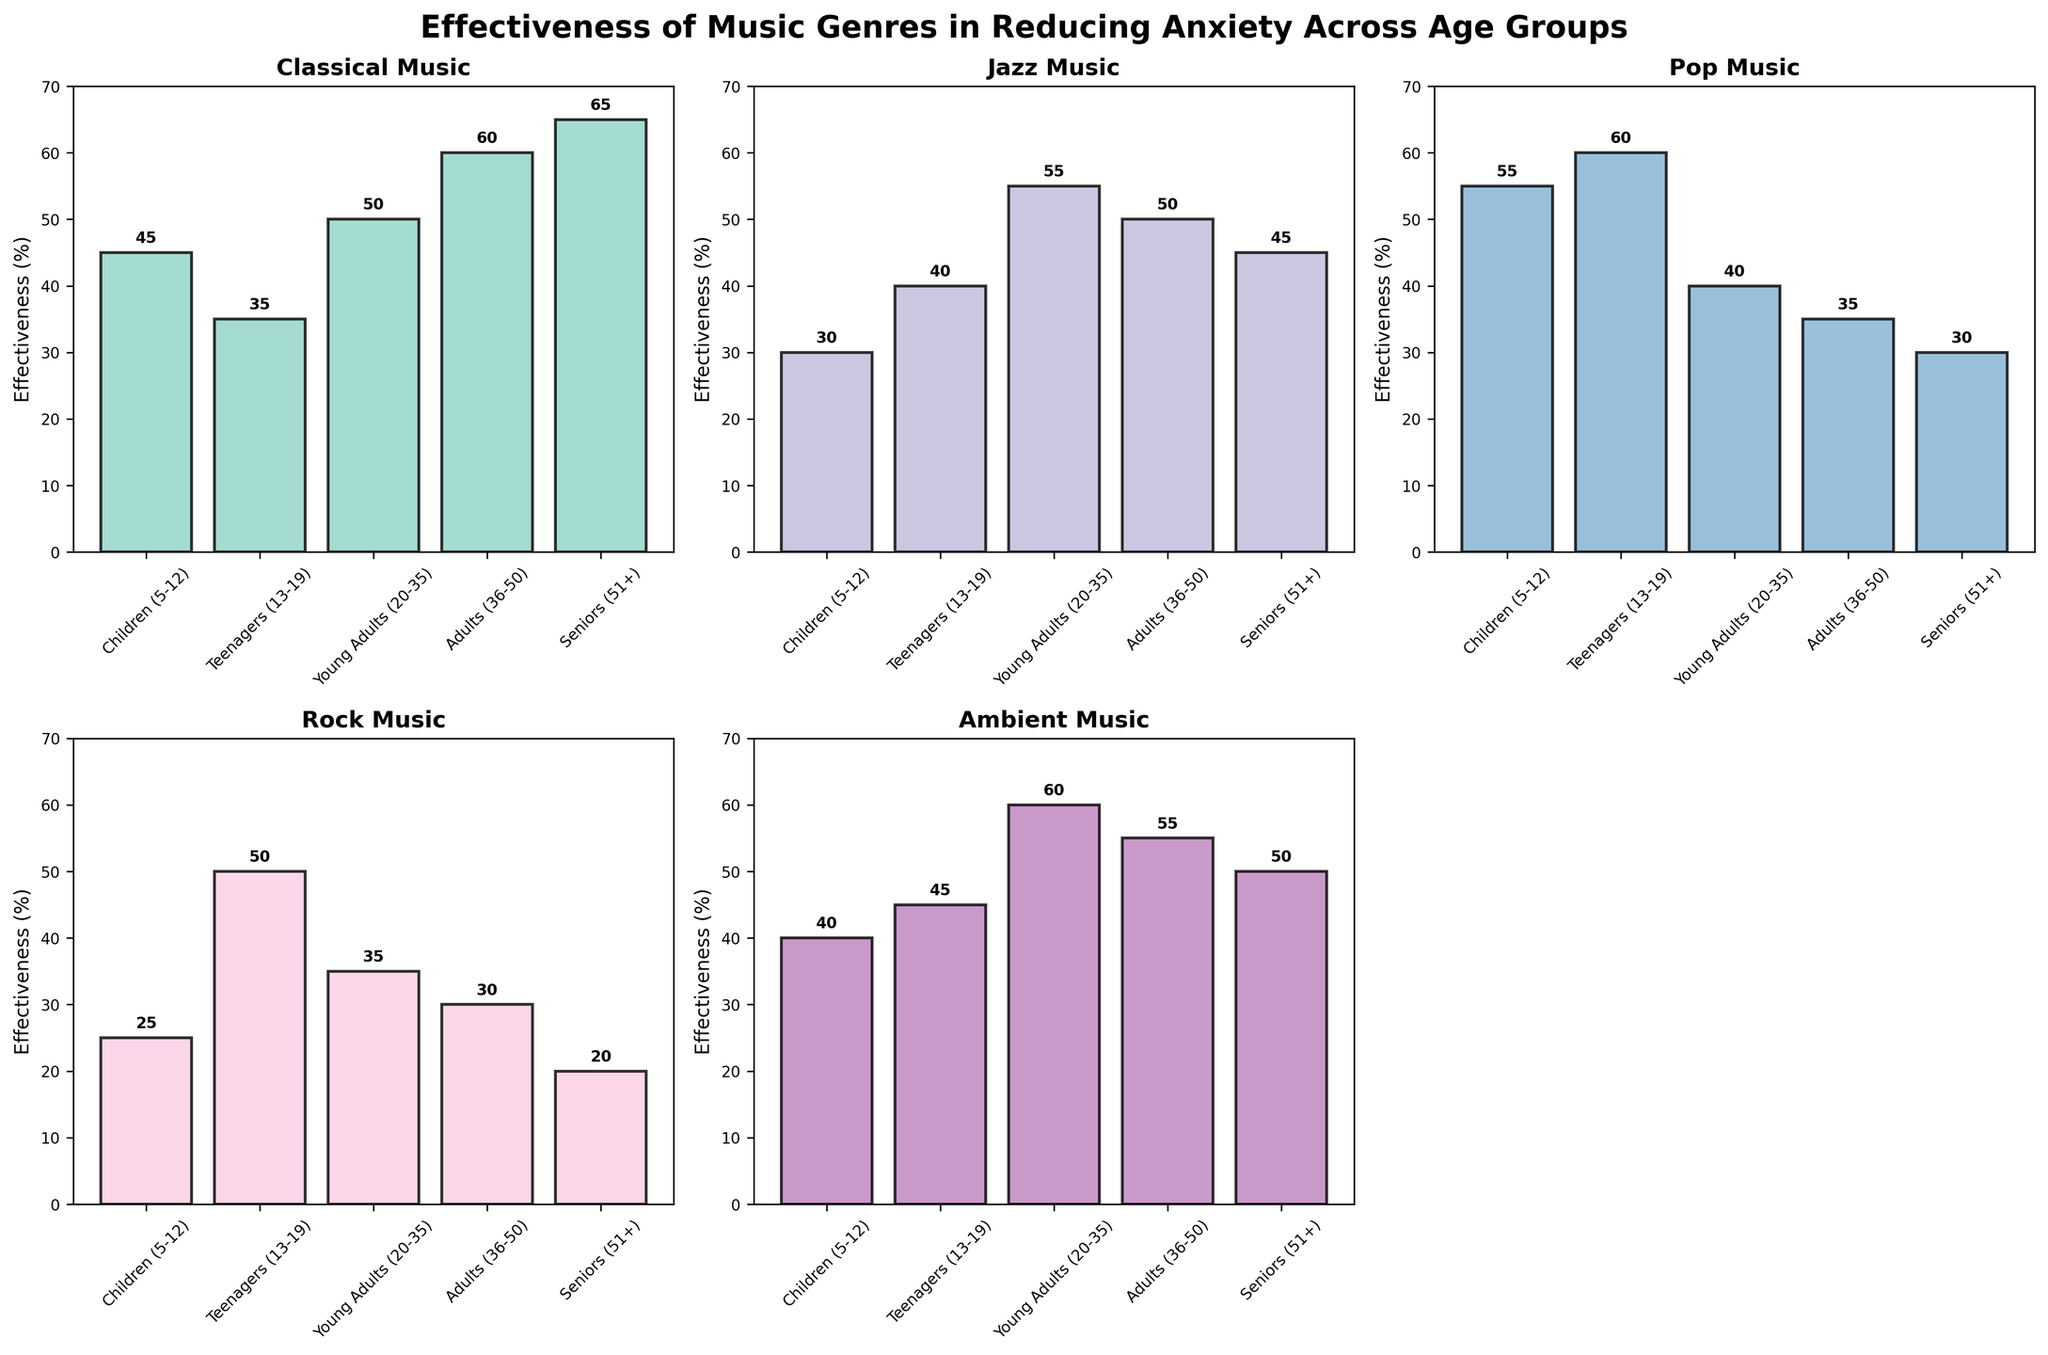What is the title of the figure? The title is displayed at the top of the figure in bold and larger font. It provides a description of what the figure is about.
Answer: Effectiveness of Music Genres in Reducing Anxiety Across Age Groups How many subplots are in the figure? The figure contains a grid of subplots; counting them reveals that there are a total of six subplots, although one is turned off to balance the layout.
Answer: 6 Which music genre is most effective in reducing anxiety for Seniors (51+)? Look at the bar heights and values in each subplot to identify which genre has the highest effectiveness value for Seniors.
Answer: Classical How does the effectiveness of Jazz music compare between Teenagers (13-19) and Adults (36-50)? Compare the heights and numbers of the Jazz bars for Teenagers and Adults. Jazz for Teenagers is at 40%, and for Adults it is at 50%.
Answer: Higher for Adults (36-50) Which age group has the least effectiveness for Rock music? Examine the bars in the Rock music subplot to find the age group with the smallest value.
Answer: Seniors (51+) What is the average effectiveness of Classical music across all age groups? Add the effectiveness values of Classical music for all age groups and divide by the number of age groups (5). Calculation: (45 + 35 + 50 + 60 + 65) / 5 = 51
Answer: 51 Which age group exhibits the highest variability in the effectiveness of different music genres? Assess the spread of values across different genres within each age group to determine which one has the highest range (difference between highest and lowest value).
Answer: Teenagers (13-19) For which genre is the effectiveness most evenly distributed across age groups? Compare the bars' heights in each subplot to find the genre with the least variability across age groups.
Answer: Ambient Which genre shows the least effectiveness for Young Adults (20-35)? Identify the lowest bar and its corresponding genre for Young Adults.
Answer: Pop How does the effectiveness of Pop music for Teenagers (13-19) compare to that for Children (5-12)? Compare the bar heights and values for Pop music between Teenagers and Children. For Teenagers it is 60%, and for Children it is 55%.
Answer: Higher for Teenagers (13-19) 